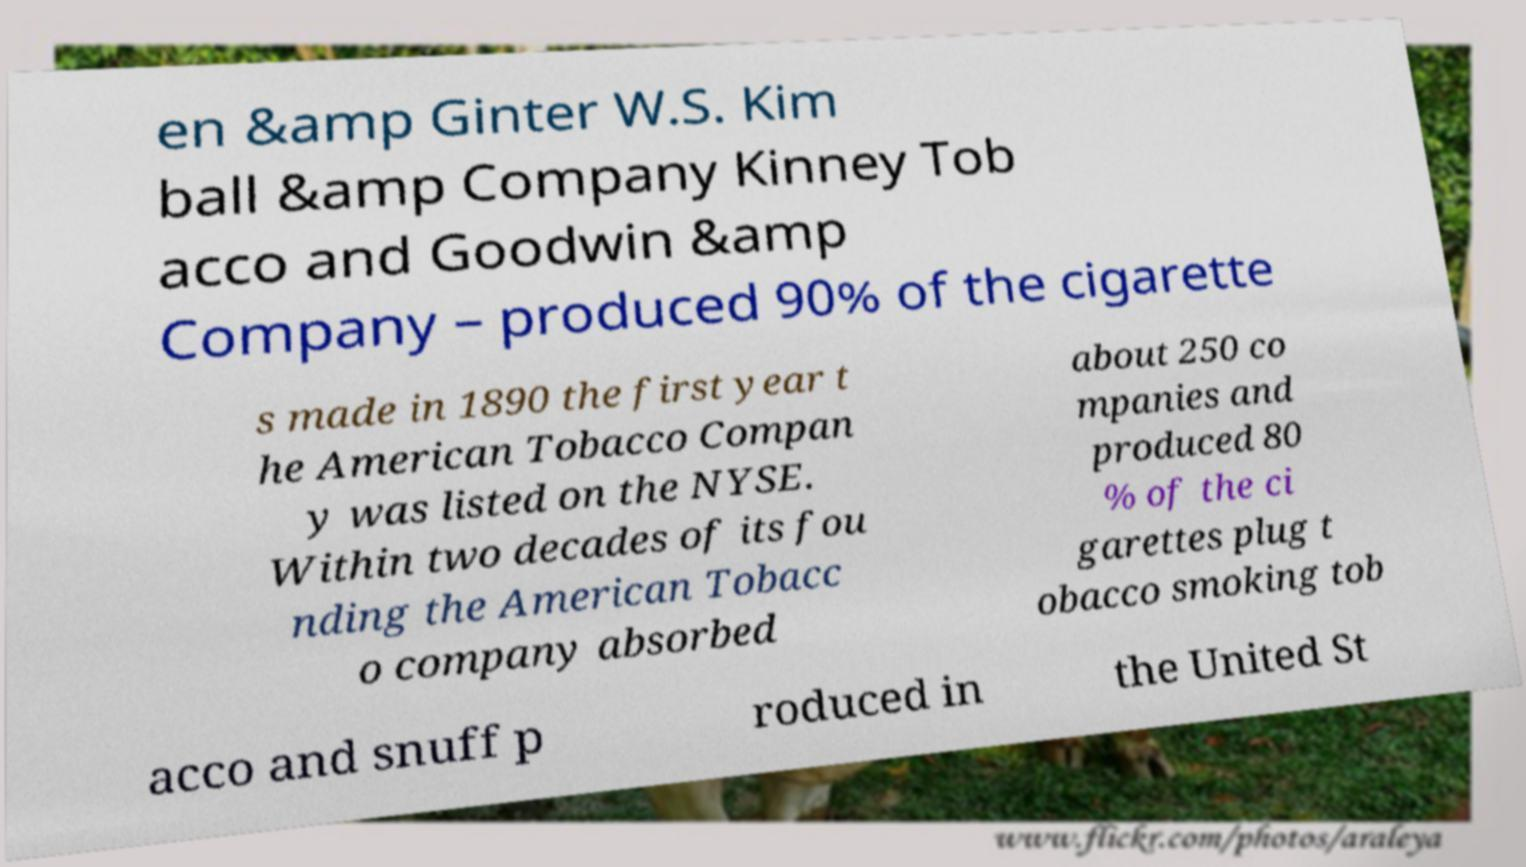Please read and relay the text visible in this image. What does it say? en &amp Ginter W.S. Kim ball &amp Company Kinney Tob acco and Goodwin &amp Company – produced 90% of the cigarette s made in 1890 the first year t he American Tobacco Compan y was listed on the NYSE. Within two decades of its fou nding the American Tobacc o company absorbed about 250 co mpanies and produced 80 % of the ci garettes plug t obacco smoking tob acco and snuff p roduced in the United St 